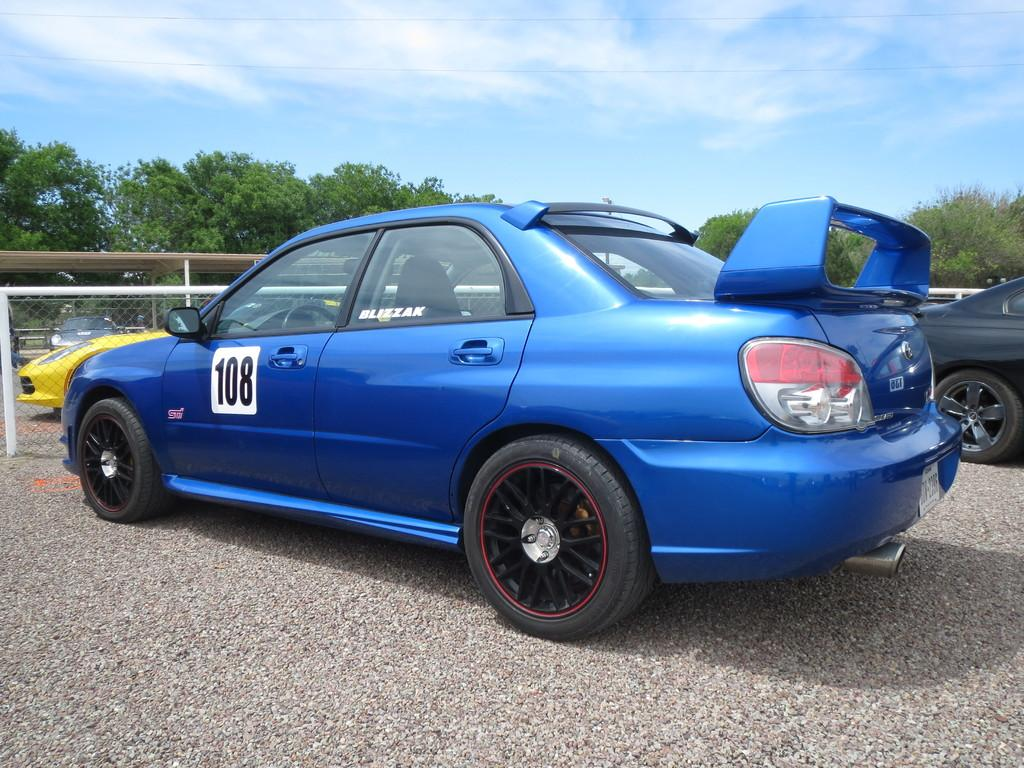What type of objects are on the ground in the image? There are vehicles on the ground in the image. Can you describe the color of the car in the front? The car in the front is blue in color. What can be seen in the background of the image? There are trees, a fence, and the sky visible in the background of the image. What sense is being used by the vehicles in the image? Vehicles do not have senses, as they are inanimate objects. How does the driver control the throat of the vehicle in the image? Vehicles do not have throats, as they are not living beings. 